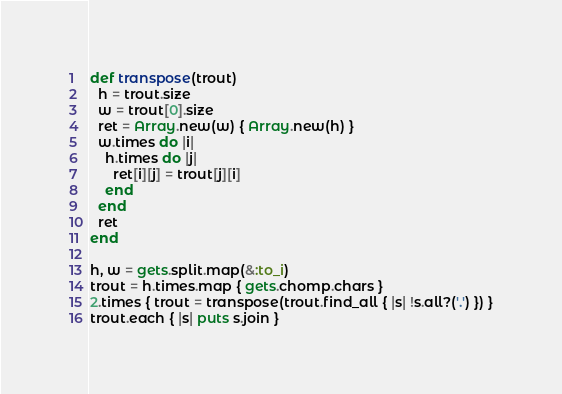<code> <loc_0><loc_0><loc_500><loc_500><_Ruby_>def transpose(trout)
  h = trout.size
  w = trout[0].size
  ret = Array.new(w) { Array.new(h) }
  w.times do |i|
    h.times do |j|
      ret[i][j] = trout[j][i]
    end
  end
  ret
end

h, w = gets.split.map(&:to_i)
trout = h.times.map { gets.chomp.chars }
2.times { trout = transpose(trout.find_all { |s| !s.all?('.') }) }
trout.each { |s| puts s.join }</code> 